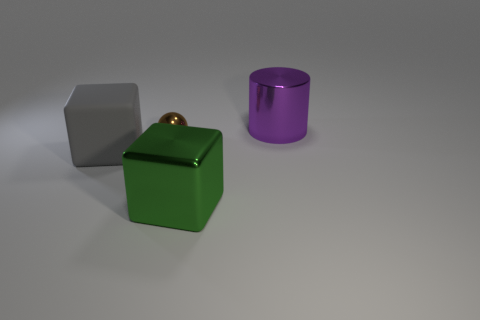Add 1 small red matte spheres. How many objects exist? 5 Subtract all green cubes. How many cubes are left? 1 Add 2 large metallic blocks. How many large metallic blocks are left? 3 Add 3 cubes. How many cubes exist? 5 Subtract 0 yellow spheres. How many objects are left? 4 Subtract all cylinders. How many objects are left? 3 Subtract 1 balls. How many balls are left? 0 Subtract all green spheres. Subtract all red cubes. How many spheres are left? 1 Subtract all purple spheres. How many brown cubes are left? 0 Subtract all tiny yellow shiny cubes. Subtract all tiny objects. How many objects are left? 3 